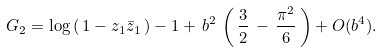Convert formula to latex. <formula><loc_0><loc_0><loc_500><loc_500>G _ { 2 } = \log \, ( \, 1 - z _ { 1 } \bar { z } _ { 1 } \, ) - 1 + \, b ^ { 2 } \, \left ( \, \frac { 3 } { 2 } \, - \, \frac { \pi ^ { 2 } } { 6 } \, \right ) + O ( b ^ { 4 } ) .</formula> 